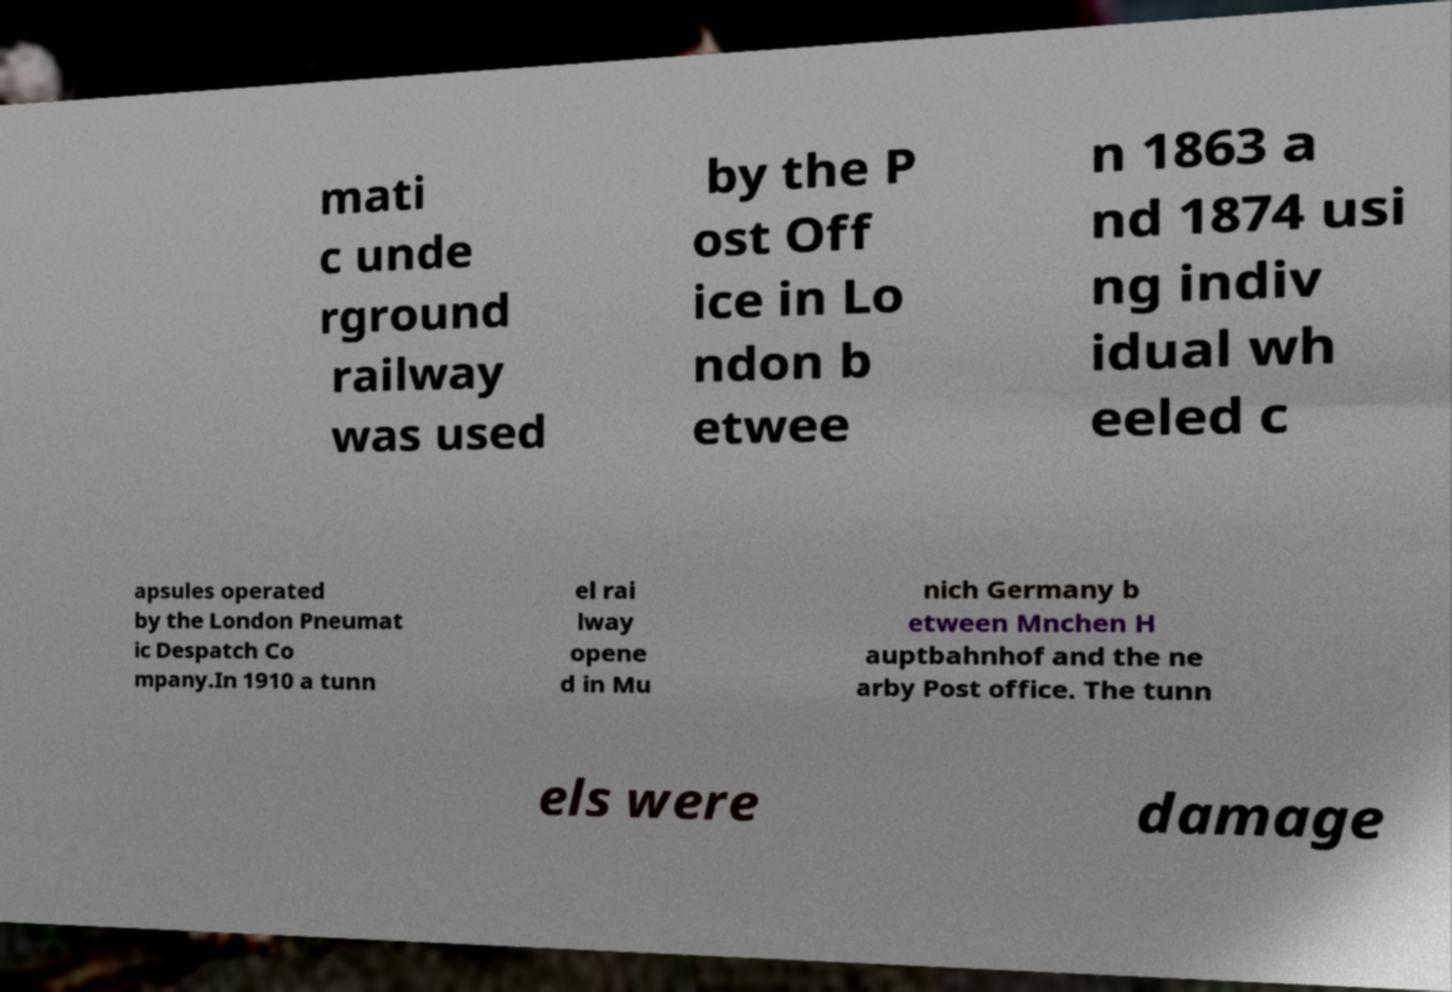Could you assist in decoding the text presented in this image and type it out clearly? mati c unde rground railway was used by the P ost Off ice in Lo ndon b etwee n 1863 a nd 1874 usi ng indiv idual wh eeled c apsules operated by the London Pneumat ic Despatch Co mpany.In 1910 a tunn el rai lway opene d in Mu nich Germany b etween Mnchen H auptbahnhof and the ne arby Post office. The tunn els were damage 